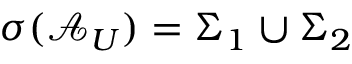Convert formula to latex. <formula><loc_0><loc_0><loc_500><loc_500>\sigma ( \mathcal { A } _ { U } ) = \Sigma _ { 1 } \cup \Sigma _ { 2 }</formula> 